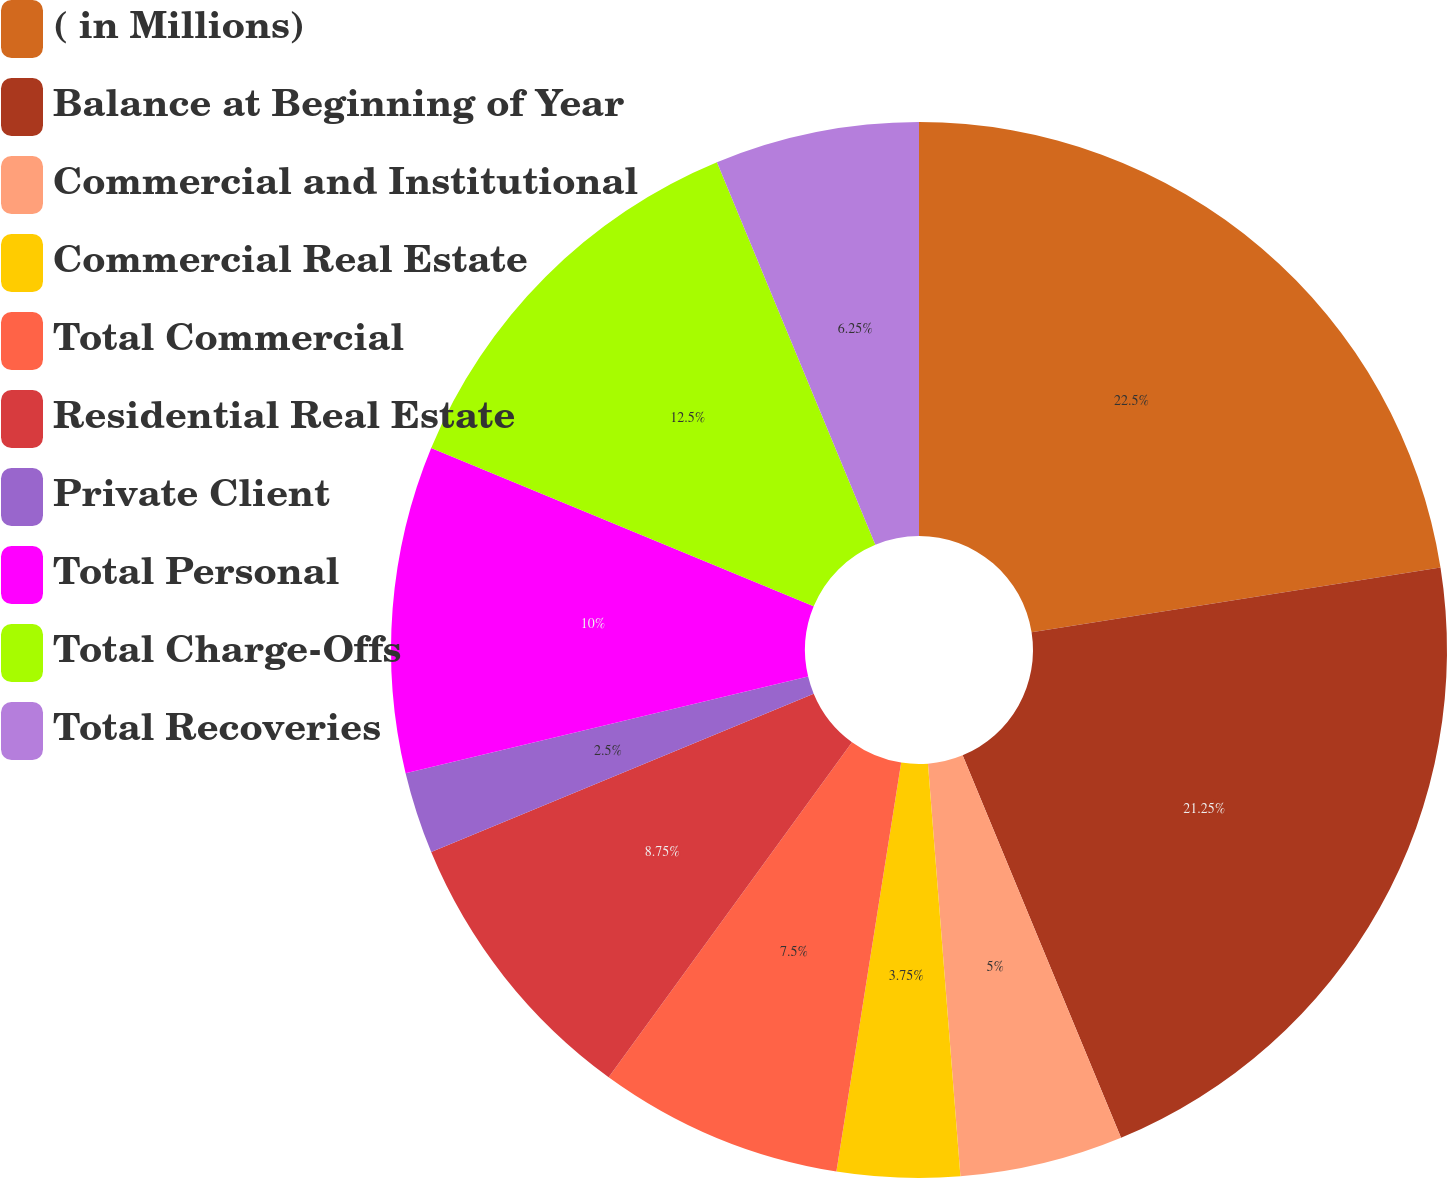Convert chart. <chart><loc_0><loc_0><loc_500><loc_500><pie_chart><fcel>( in Millions)<fcel>Balance at Beginning of Year<fcel>Commercial and Institutional<fcel>Commercial Real Estate<fcel>Total Commercial<fcel>Residential Real Estate<fcel>Private Client<fcel>Total Personal<fcel>Total Charge-Offs<fcel>Total Recoveries<nl><fcel>22.5%<fcel>21.25%<fcel>5.0%<fcel>3.75%<fcel>7.5%<fcel>8.75%<fcel>2.5%<fcel>10.0%<fcel>12.5%<fcel>6.25%<nl></chart> 